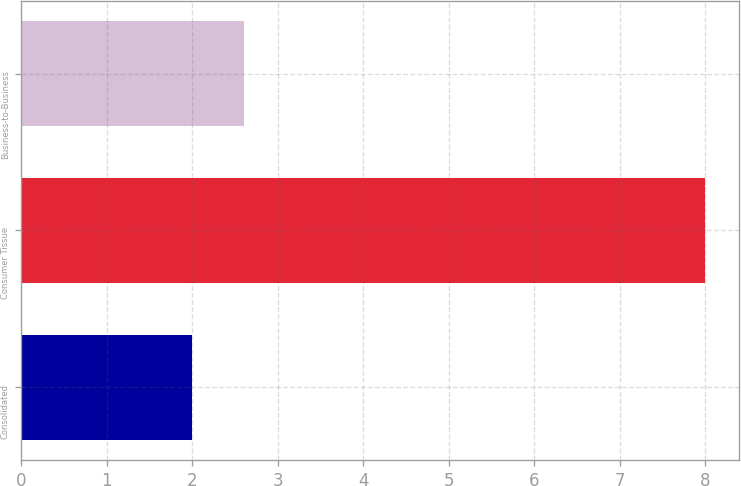Convert chart. <chart><loc_0><loc_0><loc_500><loc_500><bar_chart><fcel>Consolidated<fcel>Consumer Tissue<fcel>Business-to-Business<nl><fcel>2<fcel>8<fcel>2.6<nl></chart> 